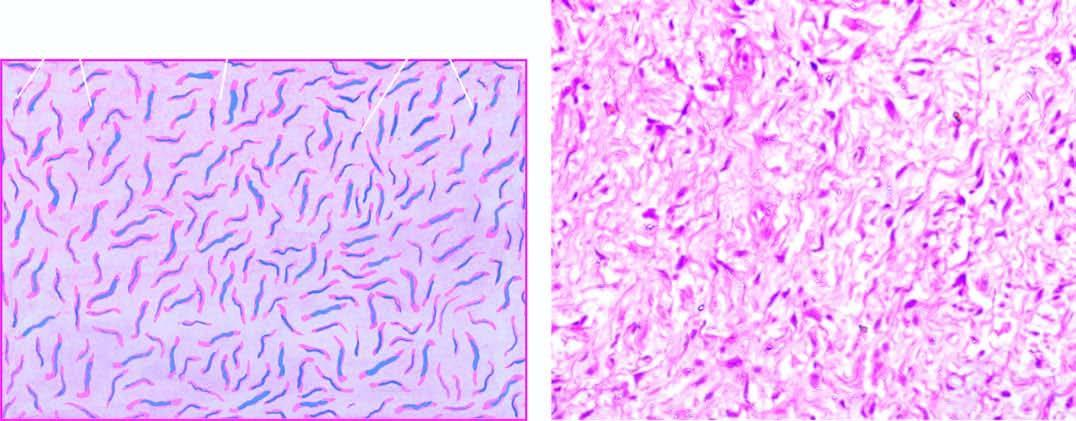what have wavy nuclei?
Answer the question using a single word or phrase. Cells 